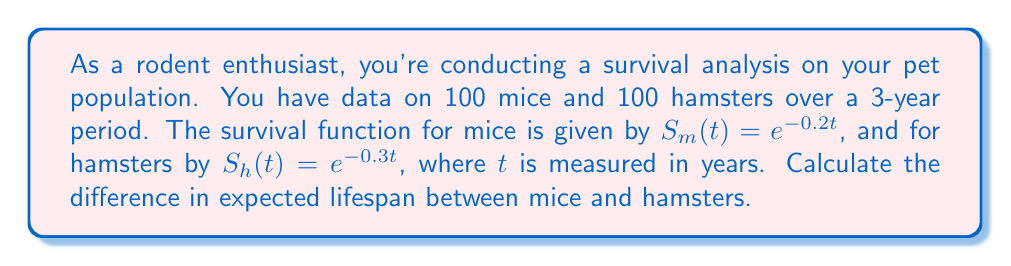Provide a solution to this math problem. To solve this problem, we'll follow these steps:

1) The expected lifespan for a continuous random variable with survival function $S(t)$ is given by:

   $$E[T] = \int_0^\infty S(t) dt$$

2) For mice, we have $S_m(t) = e^{-0.2t}$. Let's calculate their expected lifespan:

   $$E[T_m] = \int_0^\infty e^{-0.2t} dt$$

   $$= [-\frac{1}{0.2}e^{-0.2t}]_0^\infty$$

   $$= 0 - (-\frac{1}{0.2}) = 5 \text{ years}$$

3) For hamsters, we have $S_h(t) = e^{-0.3t}$. Their expected lifespan is:

   $$E[T_h] = \int_0^\infty e^{-0.3t} dt$$

   $$= [-\frac{1}{0.3}e^{-0.3t}]_0^\infty$$

   $$= 0 - (-\frac{1}{0.3}) = \frac{10}{3} \text{ years}$$

4) The difference in expected lifespan is:

   $$E[T_m] - E[T_h] = 5 - \frac{10}{3} = \frac{15}{3} - \frac{10}{3} = \frac{5}{3} \text{ years}$$
Answer: $\frac{5}{3}$ years 